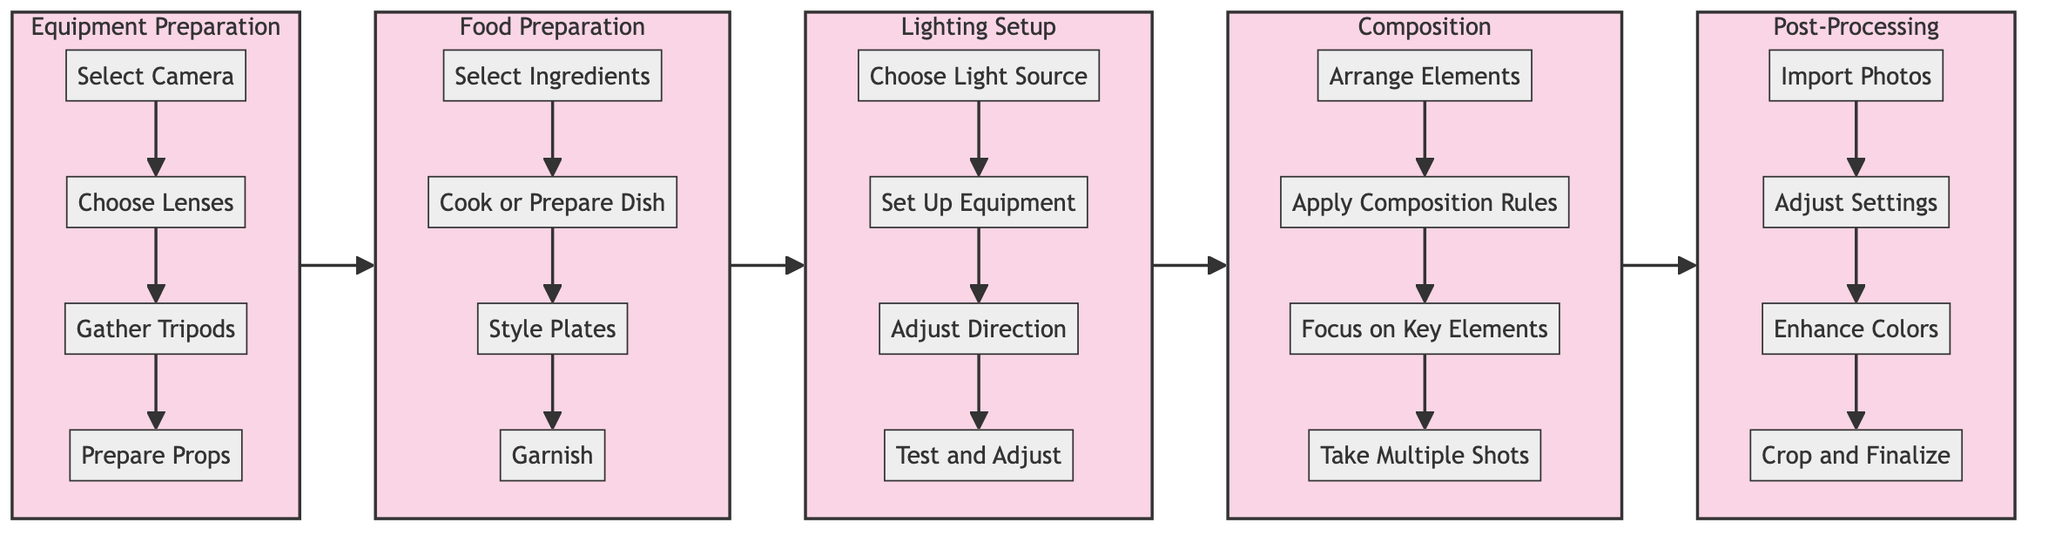What is the first step in the Equipment Preparation stage? The first step in the Equipment Preparation stage is labeled as "Select Camera," which is the first node in that subgraph.
Answer: Select Camera How many steps are there in the Food Preparation stage? The Food Preparation stage contains four steps, as indicated by the four nodes present in the subgraph labeled FP.
Answer: 4 Which stage follows the Lighting Setup? The stage that follows the Lighting Setup is labeled as "Composition," as indicated by the flow from the last node of the Lighting Setup subgraph to the first node of the Composition subgraph.
Answer: Composition What is the last step in the Post-Processing stage? The last step in the Post-Processing stage is "Crop and Finalize," which is the last node in that subgraph.
Answer: Crop and Finalize What are the total number of stages in the diagram? The diagram consists of five stages: Equipment Preparation, Food Preparation, Lighting Setup, Composition, and Post-Processing, making the total count five.
Answer: 5 How does the Food Preparation step relate to Equipment Preparation? The Food Preparation stage immediately follows the Equipment Preparation stage in the flowchart, indicating a sequential relationship where Food Preparation occurs after Equipment Preparation.
Answer: Food Preparation follows Equipment Preparation Which node is common topic across all stages in the process? The common topic across all stages in the process is "Preparation," as each stage focuses on a form of preparation including equipment, food, lighting, composition, and post-processing.
Answer: Preparation What is the equipment mentioned in the Lighting Setup stage? The Lighting Setup stage mentions "softboxes" and "reflectors" as equipment to be set up, as indicated by the specific steps laid out in that subgraph.
Answer: softboxes and reflectors In which stage do we focus on key elements like textures and colors? Focusing on key elements like textures and colors occurs in the Composition stage, as stated in the respective node within that subgraph.
Answer: Composition 